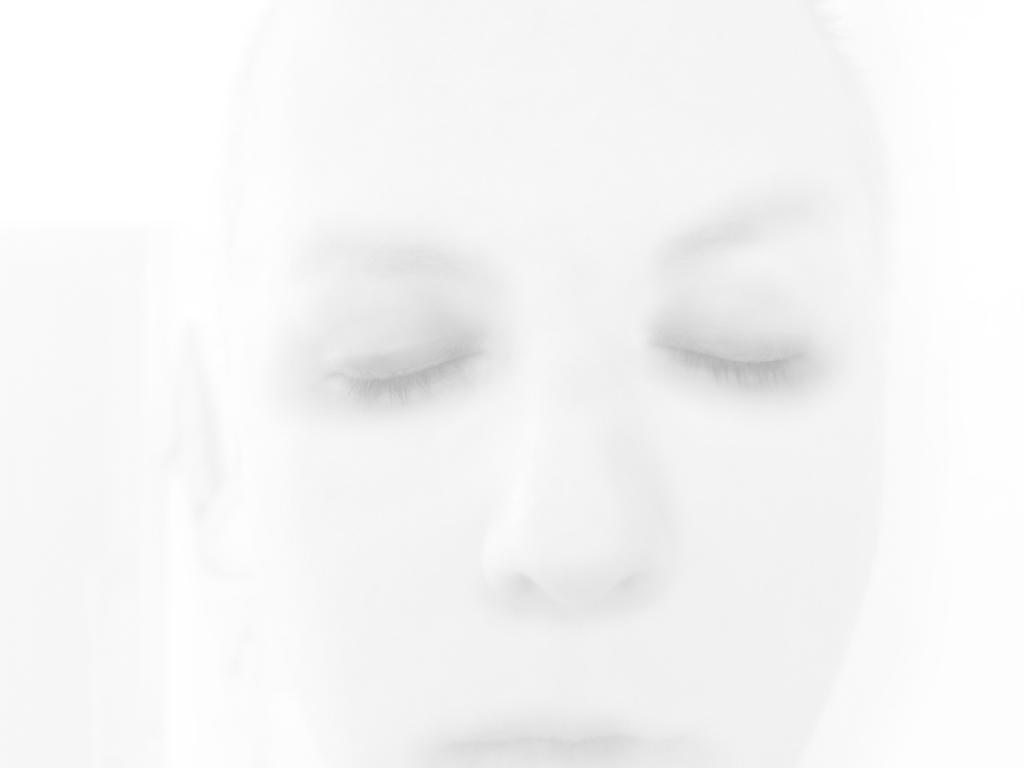What is the color scheme of the picture? The picture is black and white. Can you describe the main subject of the image? There is a person in the picture. What type of insect can be seen crawling on the dinner table in the image? There is no dinner table or insect present in the image; it is a black and white picture featuring a person. 